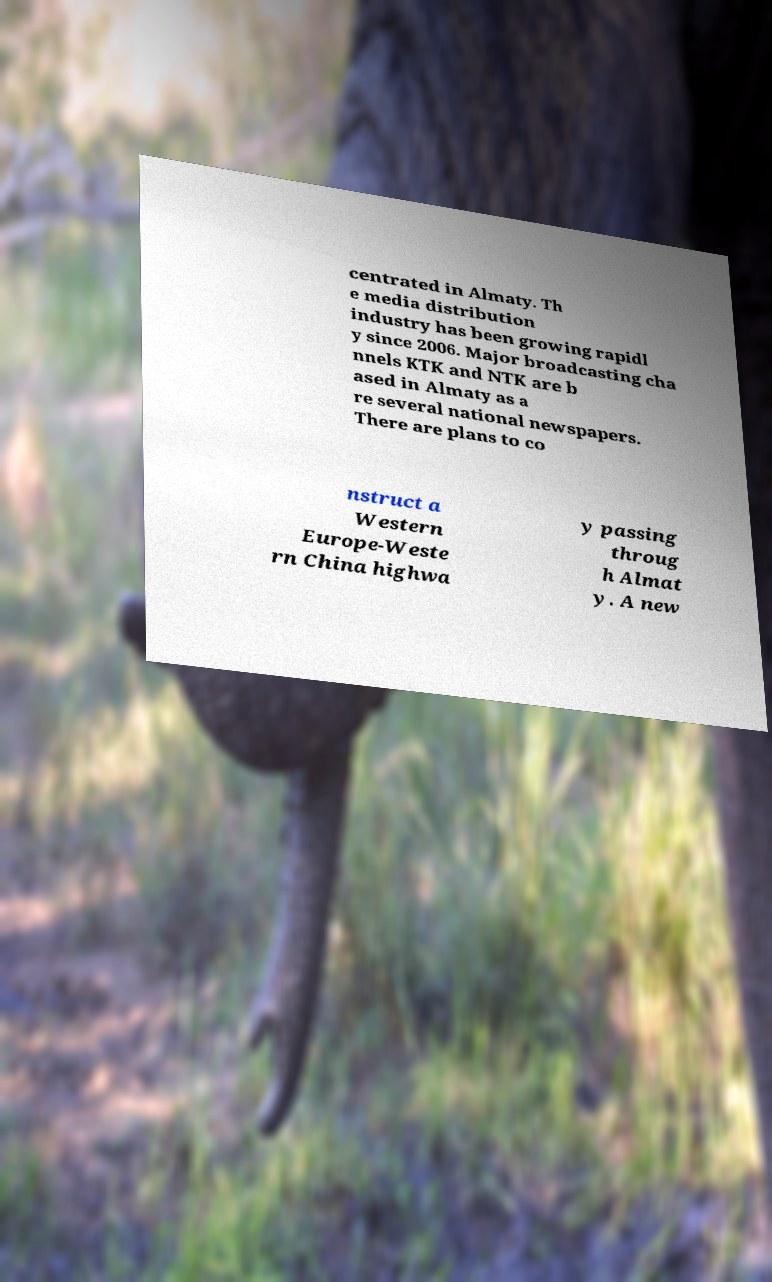For documentation purposes, I need the text within this image transcribed. Could you provide that? centrated in Almaty. Th e media distribution industry has been growing rapidl y since 2006. Major broadcasting cha nnels KTK and NTK are b ased in Almaty as a re several national newspapers. There are plans to co nstruct a Western Europe-Weste rn China highwa y passing throug h Almat y. A new 